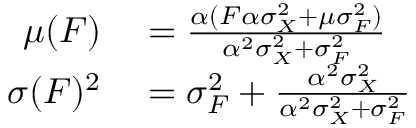<formula> <loc_0><loc_0><loc_500><loc_500>\begin{array} { r l } { \mu ( F ) } & = \frac { \alpha ( F \alpha \sigma _ { X } ^ { 2 } + \mu \sigma _ { F } ^ { 2 } ) } { \alpha ^ { 2 } \sigma _ { X } ^ { 2 } + \sigma _ { F } ^ { 2 } } } \\ { \sigma ( F ) ^ { 2 } } & = \sigma _ { F } ^ { 2 } + \frac { \alpha ^ { 2 } \sigma _ { X } ^ { 2 } } { \alpha ^ { 2 } \sigma _ { X } ^ { 2 } + \sigma _ { F } ^ { 2 } } } \end{array}</formula> 